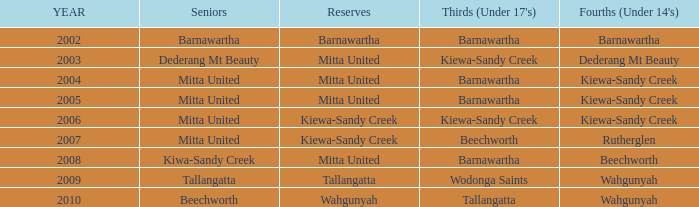Which Seniors have YEAR before 2006, and Fourths (Under 14's) of kiewa-sandy creek? Mitta United, Mitta United. 